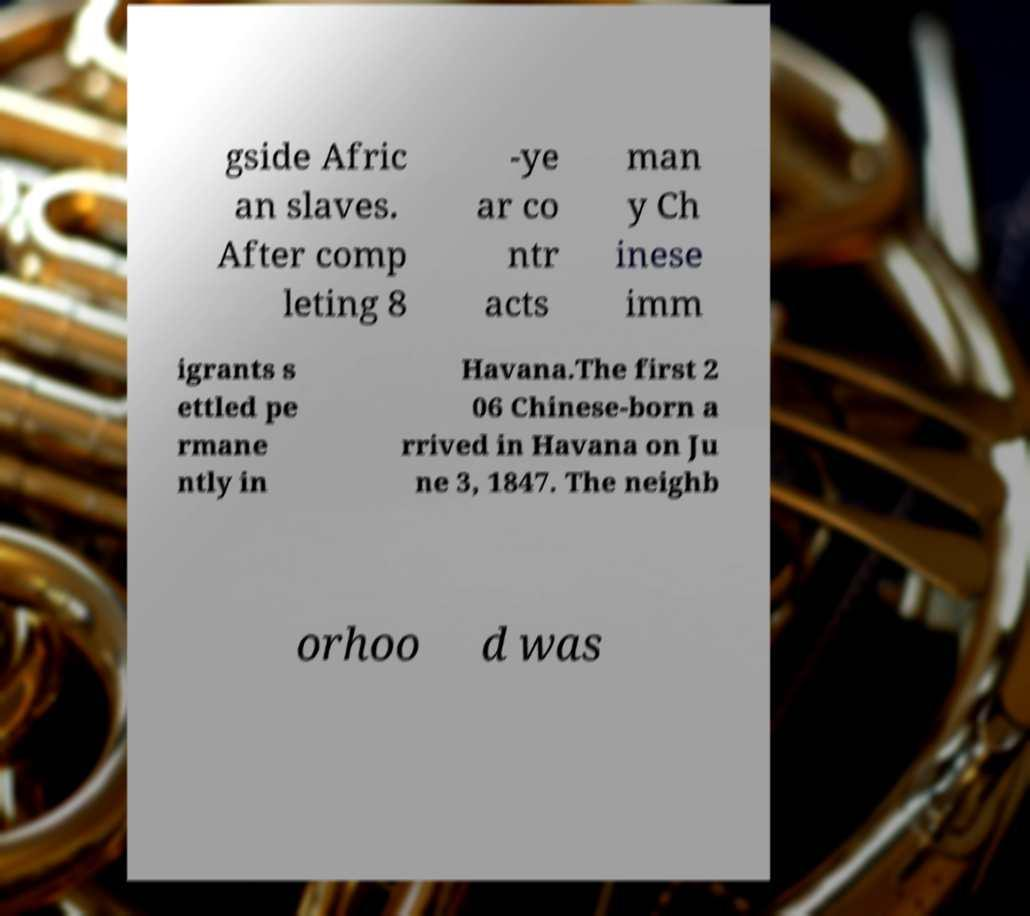There's text embedded in this image that I need extracted. Can you transcribe it verbatim? gside Afric an slaves. After comp leting 8 -ye ar co ntr acts man y Ch inese imm igrants s ettled pe rmane ntly in Havana.The first 2 06 Chinese-born a rrived in Havana on Ju ne 3, 1847. The neighb orhoo d was 